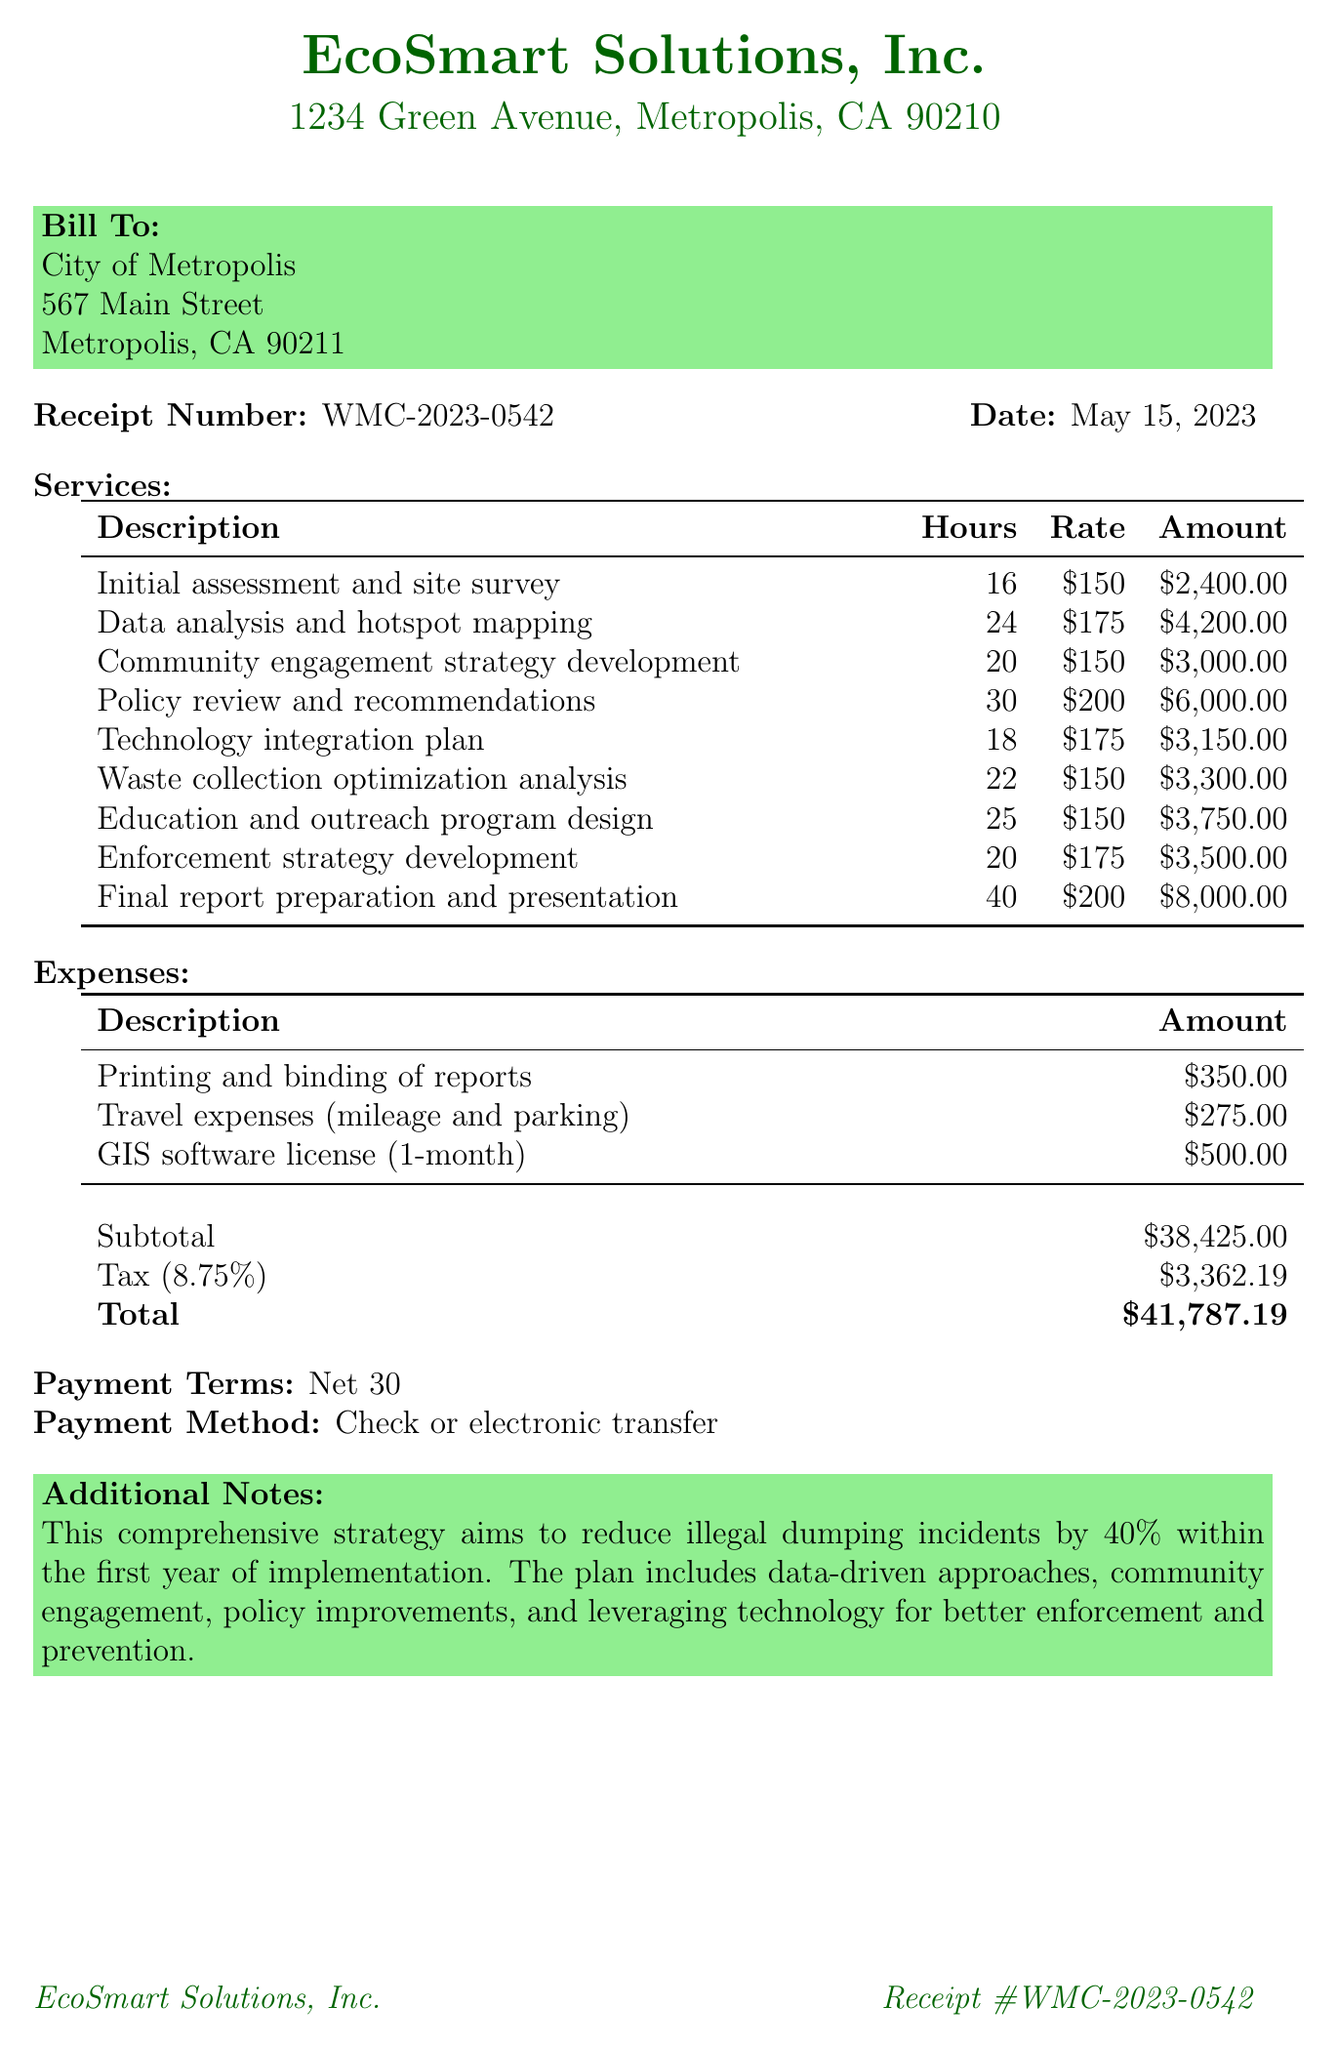what is the name of the consultant? The consultant's name is listed at the top of the receipt.
Answer: EcoSmart Solutions, Inc what is the total amount due? The total amount is specified at the bottom of the receipt.
Answer: $41,787.19 how many hours were billed for the policy review and recommendations? The hours for this service are detailed in the services section.
Answer: 30 what is the address of the client? The client's address is provided in the bill to section.
Answer: 567 Main Street, Metropolis, CA 90211 what is the tax rate applied? The tax rate can be found near the totals section of the receipt.
Answer: 8.75% how much was spent on travel expenses? The expense section lists the amount for travel expenses.
Answer: $275.00 which service incurred the highest charge? Comparing the amounts in the services section shows which is the highest.
Answer: Final report preparation and presentation what are the payment terms? The payment terms are stated towards the end of the document.
Answer: Net 30 what is the objective mentioned in the additional notes? The objective is described in the additional notes section.
Answer: Reduce illegal dumping incidents by 40% within the first year of implementation 